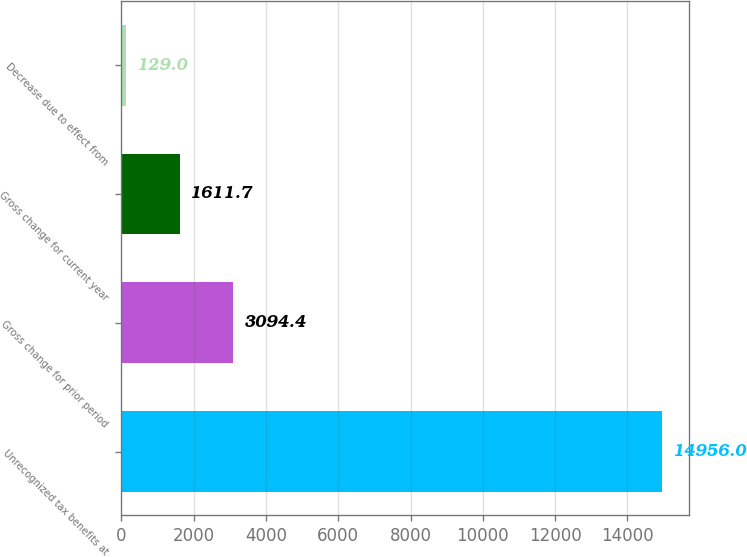Convert chart to OTSL. <chart><loc_0><loc_0><loc_500><loc_500><bar_chart><fcel>Unrecognized tax benefits at<fcel>Gross change for prior period<fcel>Gross change for current year<fcel>Decrease due to effect from<nl><fcel>14956<fcel>3094.4<fcel>1611.7<fcel>129<nl></chart> 